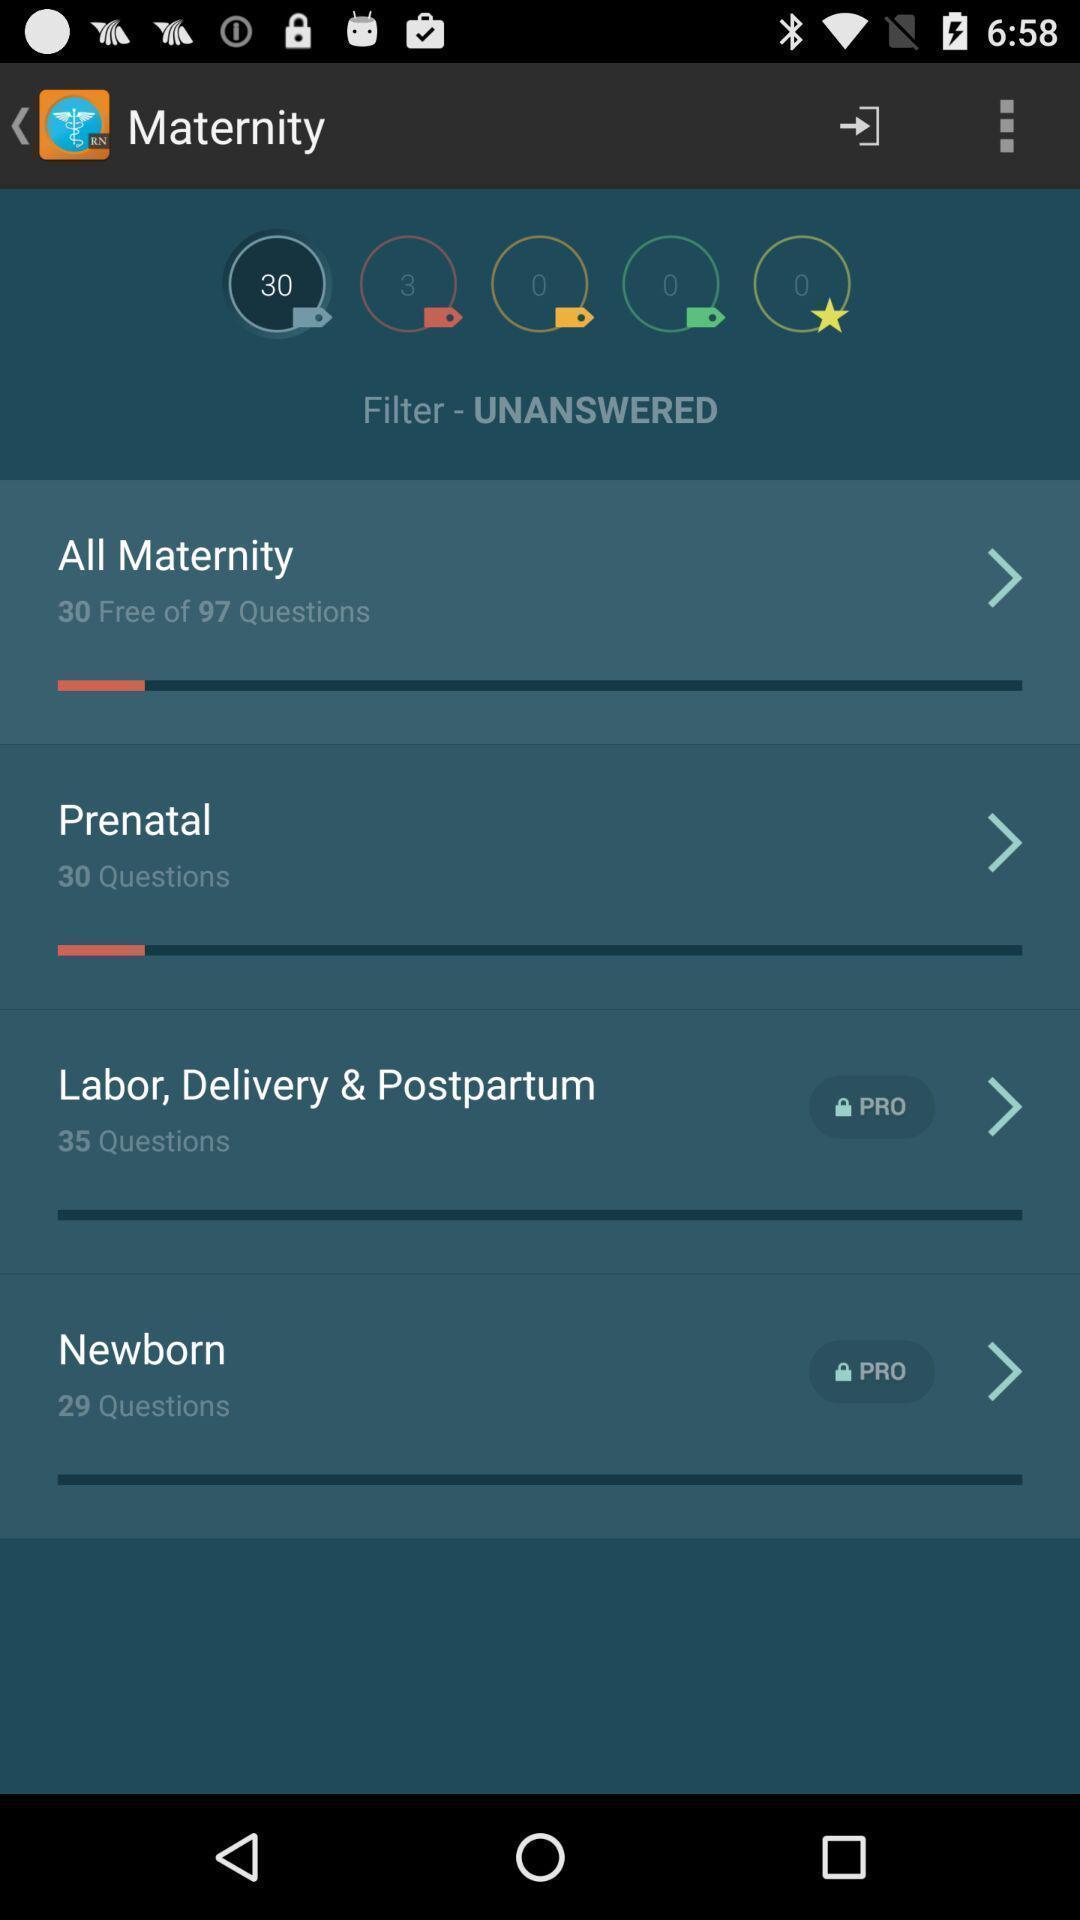Describe the visual elements of this screenshot. Screen shows maternity details in a health app. 